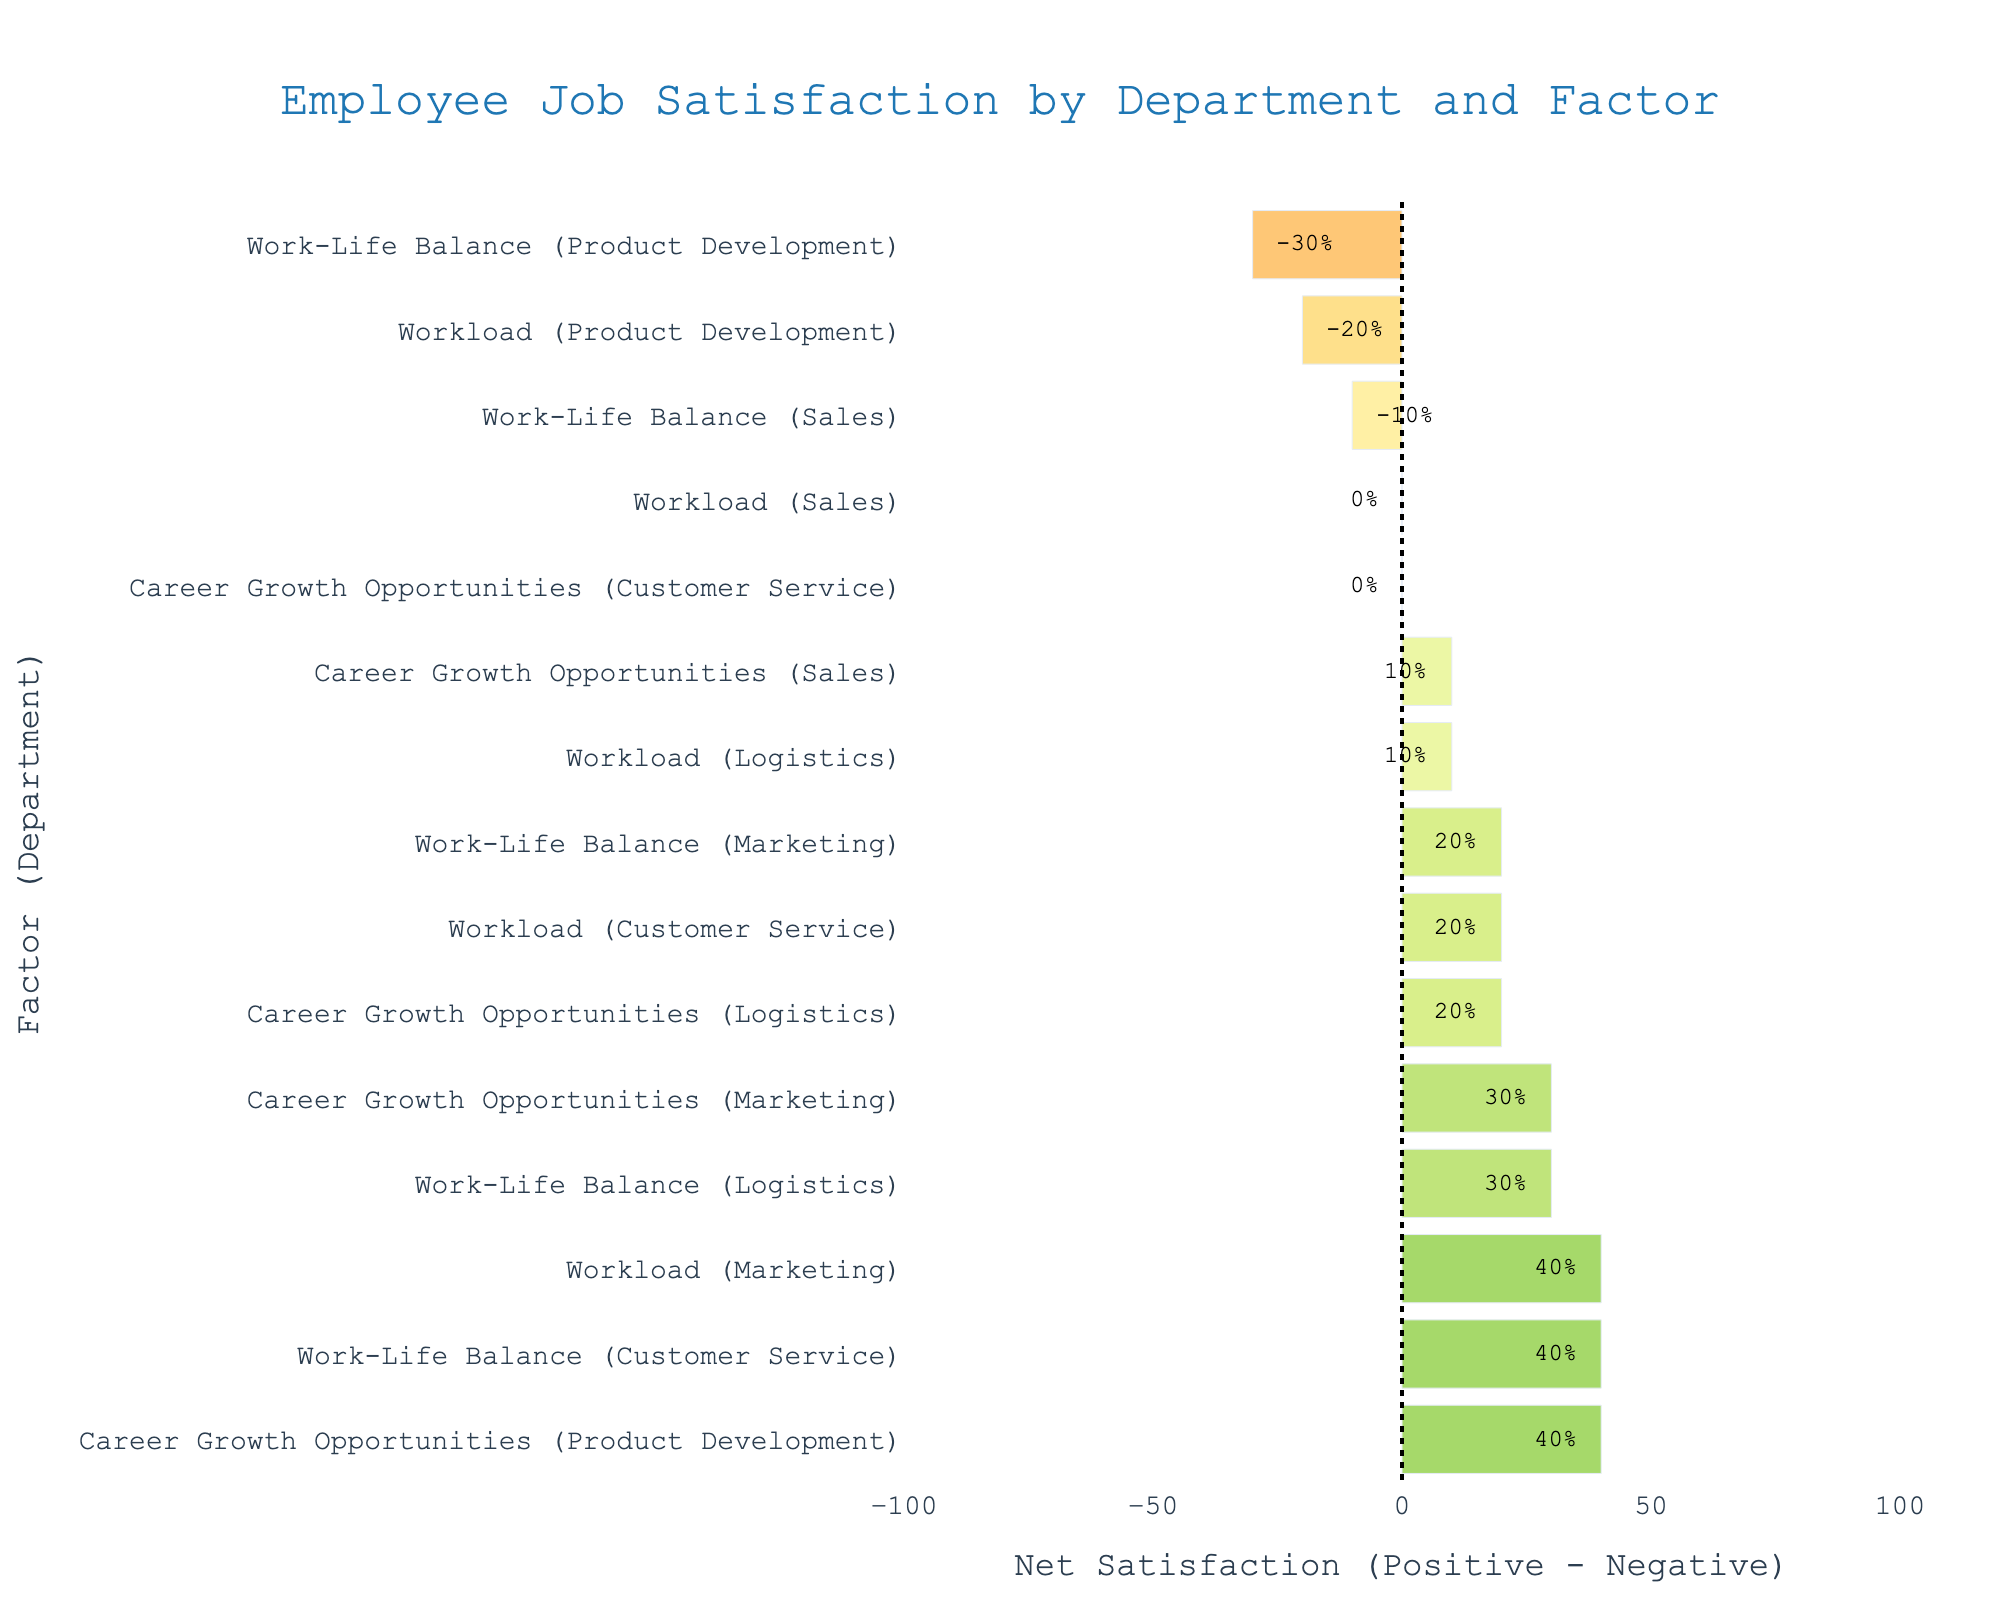Which department has the highest net job satisfaction for career growth opportunities? To find the department with the highest net satisfaction score in the category of career growth opportunities, check the length and position of the bars color-coded in green or red for each department in the "Career Growth Opportunities" row. The longest bar in green indicates the highest net satisfaction.
Answer: Product Development Which factor in the Sales department has the worst net satisfaction score? Locate the Sales department's rows and compare the net satisfaction scores for each factor. Look for the most negative value, indicated by the longest red bar.
Answer: Work-Life Balance What is the net satisfaction score for workload in Product Development? Identify the bar representing workload in the Product Development row, then read the net satisfaction score annotated on the bar.
Answer: -20% How does the net satisfaction for work-life balance in Customer Service compare to that in Logistics? Compare the lengths of the bars representing work-life balance in Customer Service and Logistics. Green indicates positive satisfaction, red indicates negative. Customer Service has a longer green bar compared to Logistics, indicating higher satisfaction.
Answer: Customer Service has higher net satisfaction What is the overall trend in net satisfaction towards career growth opportunities across all departments? Review the color and lengths of the bars related to career growth opportunities for all departments. Most bars are green, indicating a generally positive net satisfaction, with just one neutral (50% positive, 50% negative).
Answer: Generally positive net satisfaction Which factor shows the most significant dissatisfaction in any department? Look for the longest red bar across all factors and departments. It represents the highest negative net satisfaction score.
Answer: Work-Life Balance in Product Development What is the net satisfaction score for workload in Marketing, and why is it significant? Find the bar for workload in the Marketing row and read the annotated net satisfaction score. It is significant if it stands out as much higher or lower compared to other departments.
Answer: 40%; it is one of the highest net satisfaction scores in workload What can be inferred about the work-life balance satisfaction in the Product Development department? Look at the bar representing work-life balance in Product Development. Its position and color indicate a highly negative net satisfaction.
Answer: -30%; it indicates significant dissatisfaction How do the net satisfaction scores for workload compare between Customer Service and Logistics? Compare the bars representing workload for Customer Service and Logistics. Both Net Satisfaction scores are positive, with Customer Service showing a slightly higher value.
Answer: Customer Service has a higher net satisfaction Which department shows the most balanced positive and negative opinions (closest to zero net satisfaction) for any single factor, and what is that factor? Look for bars closest to the midpoint (net satisfaction zero) across all departments and factors. The shortest bar in either direction indicates balance.
Answer: Career Growth Opportunities in Customer Service 